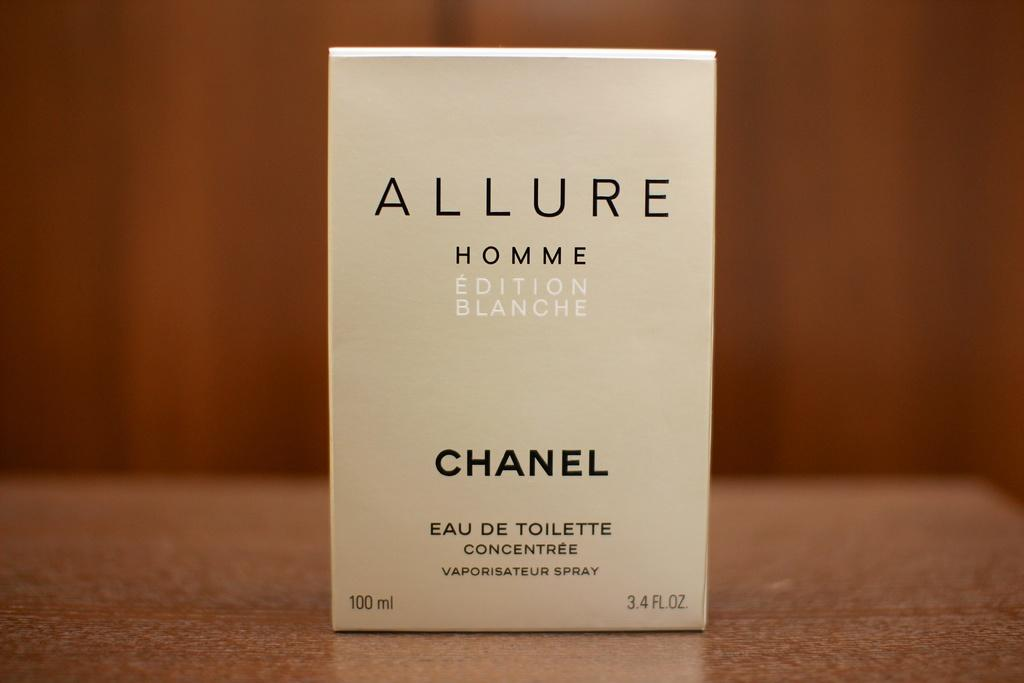<image>
Write a terse but informative summary of the picture. A box for Allure Homme Blanche edition perfume by chanel. 